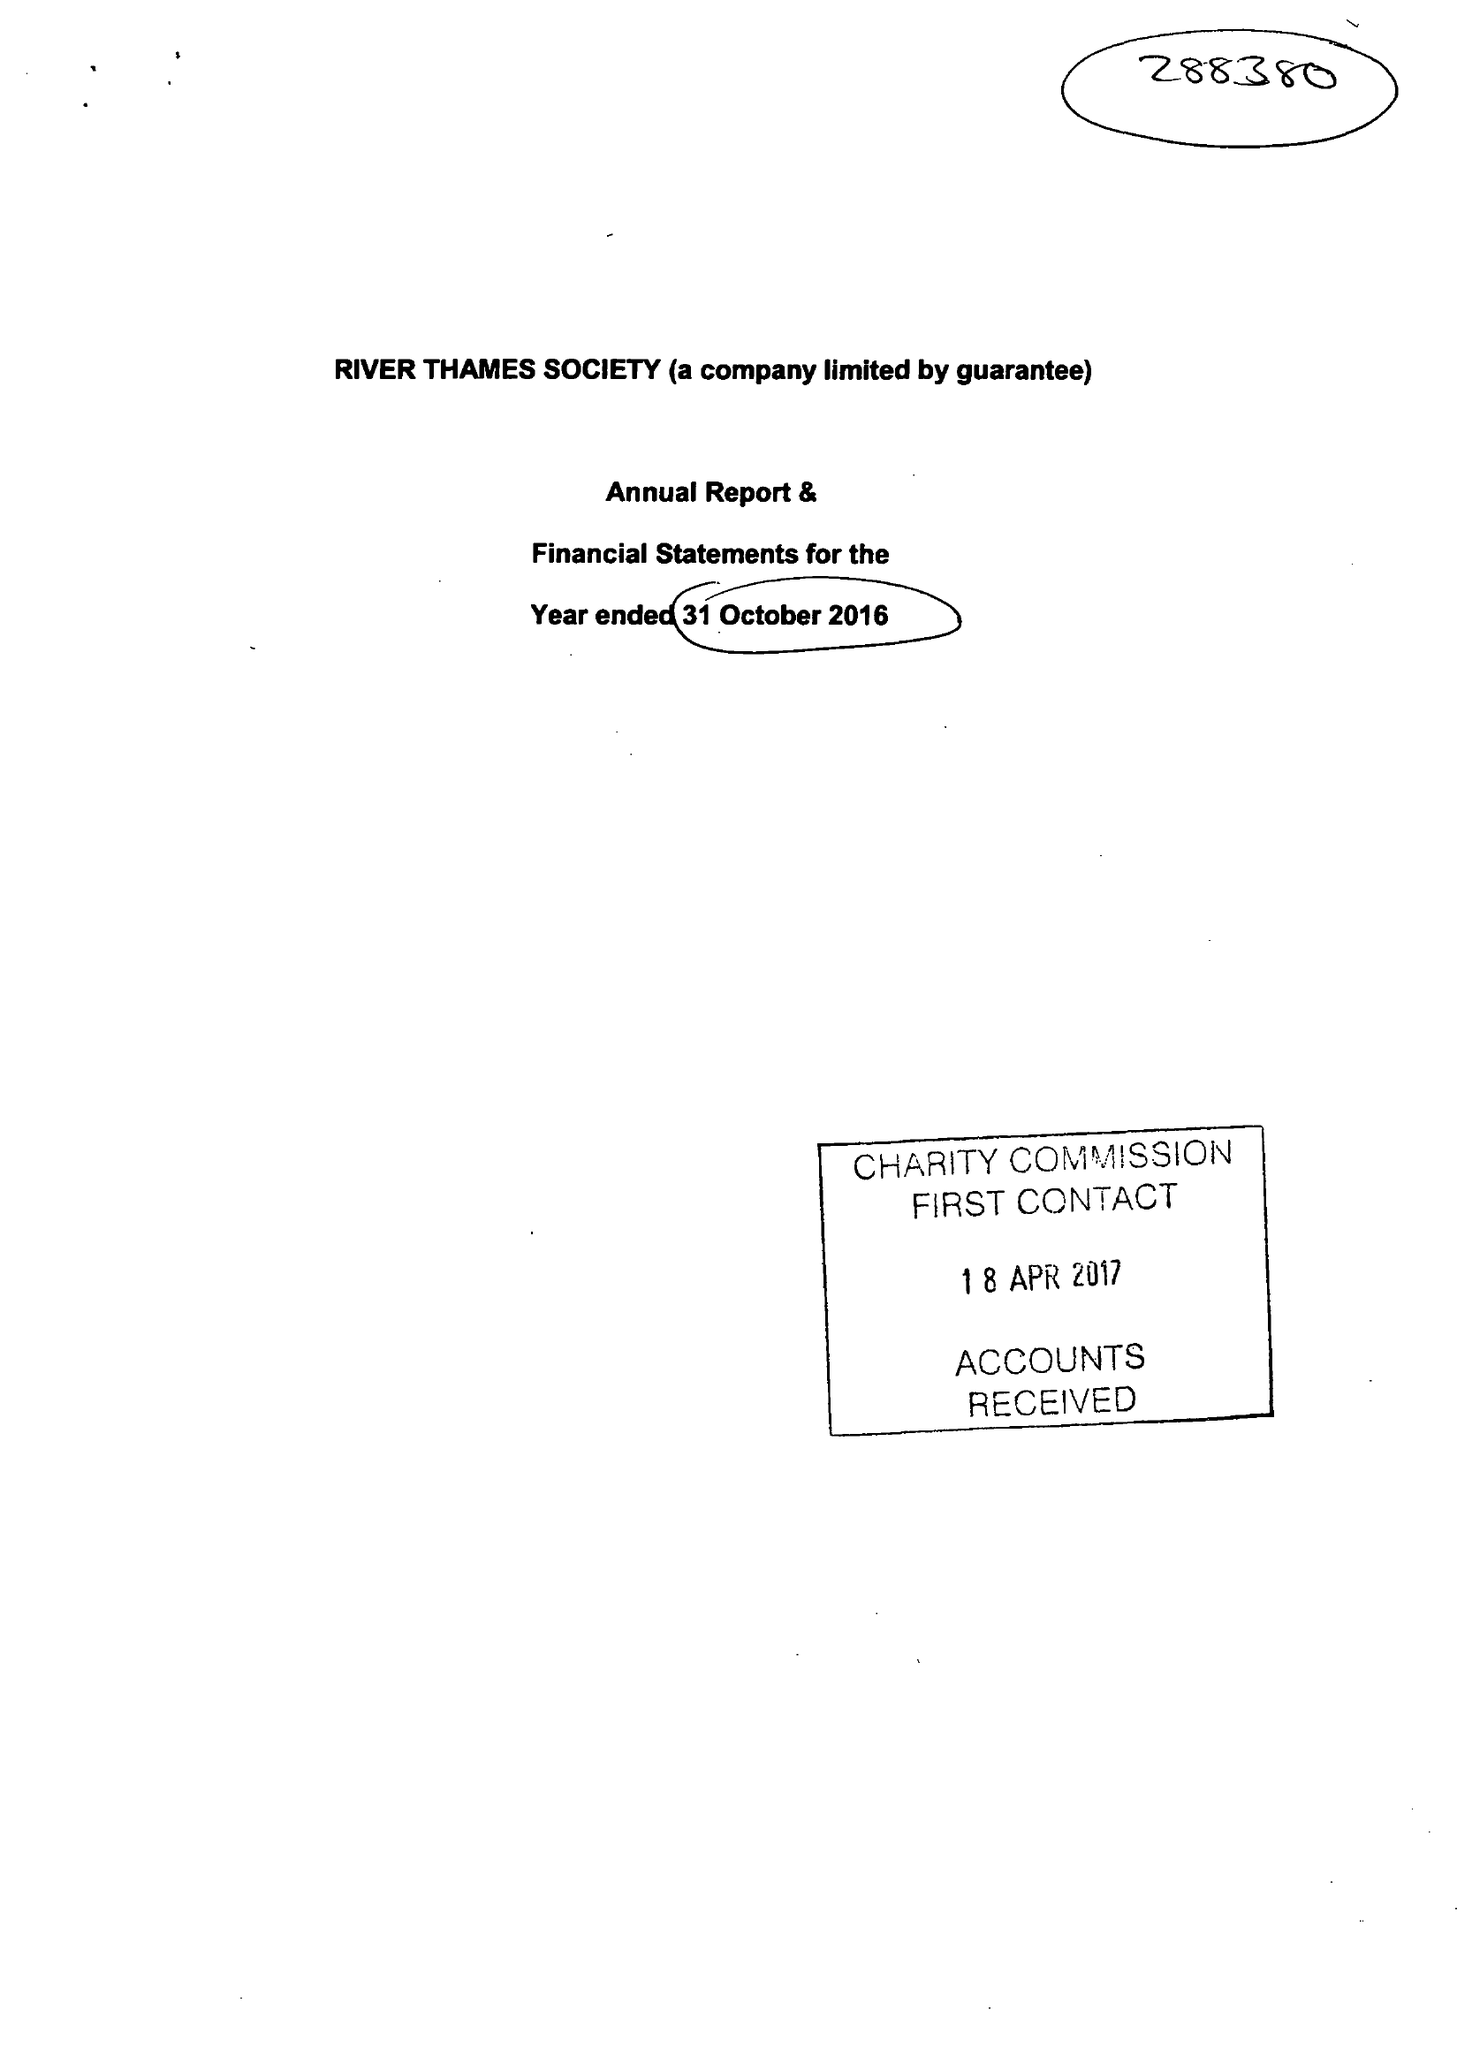What is the value for the address__postcode?
Answer the question using a single word or phrase. SL4 1JP 